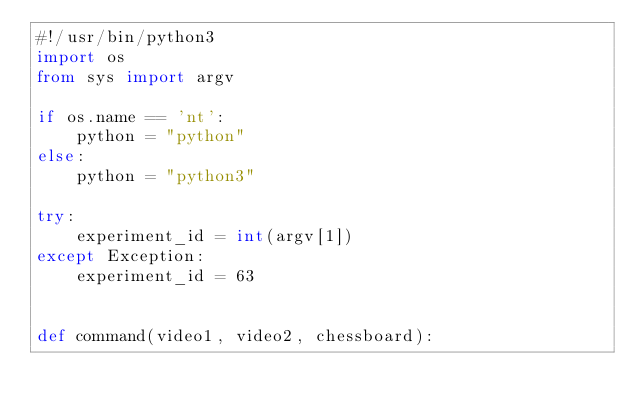Convert code to text. <code><loc_0><loc_0><loc_500><loc_500><_Python_>#!/usr/bin/python3
import os
from sys import argv

if os.name == 'nt':
    python = "python"
else:
    python = "python3"

try:
    experiment_id = int(argv[1])
except Exception:
    experiment_id = 63


def command(video1, video2, chessboard):</code> 